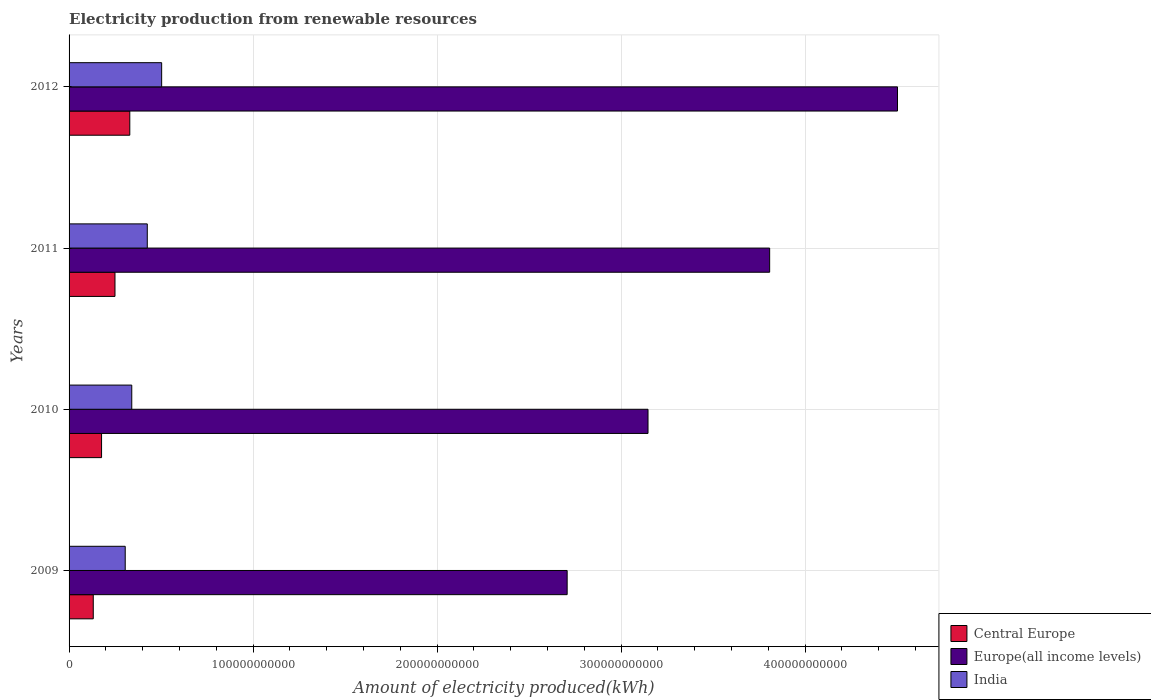How many groups of bars are there?
Make the answer very short. 4. Are the number of bars per tick equal to the number of legend labels?
Give a very brief answer. Yes. How many bars are there on the 1st tick from the bottom?
Your response must be concise. 3. What is the label of the 1st group of bars from the top?
Offer a terse response. 2012. In how many cases, is the number of bars for a given year not equal to the number of legend labels?
Offer a terse response. 0. What is the amount of electricity produced in Europe(all income levels) in 2011?
Make the answer very short. 3.81e+11. Across all years, what is the maximum amount of electricity produced in India?
Keep it short and to the point. 5.03e+1. Across all years, what is the minimum amount of electricity produced in Europe(all income levels)?
Make the answer very short. 2.71e+11. In which year was the amount of electricity produced in Central Europe minimum?
Your answer should be compact. 2009. What is the total amount of electricity produced in Central Europe in the graph?
Offer a terse response. 8.87e+1. What is the difference between the amount of electricity produced in Central Europe in 2009 and that in 2011?
Your answer should be very brief. -1.18e+1. What is the difference between the amount of electricity produced in Europe(all income levels) in 2009 and the amount of electricity produced in Central Europe in 2011?
Make the answer very short. 2.46e+11. What is the average amount of electricity produced in Central Europe per year?
Provide a short and direct response. 2.22e+1. In the year 2012, what is the difference between the amount of electricity produced in India and amount of electricity produced in Europe(all income levels)?
Ensure brevity in your answer.  -4.00e+11. What is the ratio of the amount of electricity produced in India in 2010 to that in 2011?
Keep it short and to the point. 0.8. Is the difference between the amount of electricity produced in India in 2011 and 2012 greater than the difference between the amount of electricity produced in Europe(all income levels) in 2011 and 2012?
Make the answer very short. Yes. What is the difference between the highest and the second highest amount of electricity produced in Europe(all income levels)?
Provide a short and direct response. 6.95e+1. What is the difference between the highest and the lowest amount of electricity produced in Central Europe?
Provide a succinct answer. 1.99e+1. What does the 1st bar from the top in 2009 represents?
Offer a terse response. India. What does the 2nd bar from the bottom in 2009 represents?
Make the answer very short. Europe(all income levels). What is the difference between two consecutive major ticks on the X-axis?
Your response must be concise. 1.00e+11. Where does the legend appear in the graph?
Provide a succinct answer. Bottom right. How many legend labels are there?
Offer a terse response. 3. What is the title of the graph?
Provide a short and direct response. Electricity production from renewable resources. Does "Ukraine" appear as one of the legend labels in the graph?
Provide a short and direct response. No. What is the label or title of the X-axis?
Keep it short and to the point. Amount of electricity produced(kWh). What is the label or title of the Y-axis?
Your response must be concise. Years. What is the Amount of electricity produced(kWh) of Central Europe in 2009?
Offer a very short reply. 1.31e+1. What is the Amount of electricity produced(kWh) in Europe(all income levels) in 2009?
Your answer should be very brief. 2.71e+11. What is the Amount of electricity produced(kWh) in India in 2009?
Offer a very short reply. 3.05e+1. What is the Amount of electricity produced(kWh) in Central Europe in 2010?
Your answer should be very brief. 1.77e+1. What is the Amount of electricity produced(kWh) in Europe(all income levels) in 2010?
Your answer should be very brief. 3.15e+11. What is the Amount of electricity produced(kWh) in India in 2010?
Offer a terse response. 3.41e+1. What is the Amount of electricity produced(kWh) in Central Europe in 2011?
Make the answer very short. 2.50e+1. What is the Amount of electricity produced(kWh) in Europe(all income levels) in 2011?
Give a very brief answer. 3.81e+11. What is the Amount of electricity produced(kWh) of India in 2011?
Your answer should be compact. 4.25e+1. What is the Amount of electricity produced(kWh) in Central Europe in 2012?
Offer a terse response. 3.30e+1. What is the Amount of electricity produced(kWh) in Europe(all income levels) in 2012?
Offer a terse response. 4.50e+11. What is the Amount of electricity produced(kWh) of India in 2012?
Your answer should be very brief. 5.03e+1. Across all years, what is the maximum Amount of electricity produced(kWh) in Central Europe?
Provide a succinct answer. 3.30e+1. Across all years, what is the maximum Amount of electricity produced(kWh) of Europe(all income levels)?
Give a very brief answer. 4.50e+11. Across all years, what is the maximum Amount of electricity produced(kWh) of India?
Offer a very short reply. 5.03e+1. Across all years, what is the minimum Amount of electricity produced(kWh) of Central Europe?
Keep it short and to the point. 1.31e+1. Across all years, what is the minimum Amount of electricity produced(kWh) in Europe(all income levels)?
Provide a short and direct response. 2.71e+11. Across all years, what is the minimum Amount of electricity produced(kWh) in India?
Your response must be concise. 3.05e+1. What is the total Amount of electricity produced(kWh) of Central Europe in the graph?
Provide a succinct answer. 8.87e+1. What is the total Amount of electricity produced(kWh) in Europe(all income levels) in the graph?
Ensure brevity in your answer.  1.42e+12. What is the total Amount of electricity produced(kWh) of India in the graph?
Ensure brevity in your answer.  1.57e+11. What is the difference between the Amount of electricity produced(kWh) of Central Europe in 2009 and that in 2010?
Ensure brevity in your answer.  -4.51e+09. What is the difference between the Amount of electricity produced(kWh) of Europe(all income levels) in 2009 and that in 2010?
Make the answer very short. -4.39e+1. What is the difference between the Amount of electricity produced(kWh) in India in 2009 and that in 2010?
Provide a short and direct response. -3.55e+09. What is the difference between the Amount of electricity produced(kWh) in Central Europe in 2009 and that in 2011?
Keep it short and to the point. -1.18e+1. What is the difference between the Amount of electricity produced(kWh) of Europe(all income levels) in 2009 and that in 2011?
Give a very brief answer. -1.10e+11. What is the difference between the Amount of electricity produced(kWh) of India in 2009 and that in 2011?
Your answer should be compact. -1.20e+1. What is the difference between the Amount of electricity produced(kWh) of Central Europe in 2009 and that in 2012?
Keep it short and to the point. -1.99e+1. What is the difference between the Amount of electricity produced(kWh) in Europe(all income levels) in 2009 and that in 2012?
Make the answer very short. -1.80e+11. What is the difference between the Amount of electricity produced(kWh) in India in 2009 and that in 2012?
Your response must be concise. -1.98e+1. What is the difference between the Amount of electricity produced(kWh) of Central Europe in 2010 and that in 2011?
Your answer should be compact. -7.30e+09. What is the difference between the Amount of electricity produced(kWh) in Europe(all income levels) in 2010 and that in 2011?
Keep it short and to the point. -6.61e+1. What is the difference between the Amount of electricity produced(kWh) in India in 2010 and that in 2011?
Your answer should be compact. -8.43e+09. What is the difference between the Amount of electricity produced(kWh) of Central Europe in 2010 and that in 2012?
Provide a succinct answer. -1.53e+1. What is the difference between the Amount of electricity produced(kWh) of Europe(all income levels) in 2010 and that in 2012?
Keep it short and to the point. -1.36e+11. What is the difference between the Amount of electricity produced(kWh) in India in 2010 and that in 2012?
Your response must be concise. -1.62e+1. What is the difference between the Amount of electricity produced(kWh) in Central Europe in 2011 and that in 2012?
Your answer should be very brief. -8.05e+09. What is the difference between the Amount of electricity produced(kWh) in Europe(all income levels) in 2011 and that in 2012?
Offer a very short reply. -6.95e+1. What is the difference between the Amount of electricity produced(kWh) in India in 2011 and that in 2012?
Your answer should be compact. -7.82e+09. What is the difference between the Amount of electricity produced(kWh) in Central Europe in 2009 and the Amount of electricity produced(kWh) in Europe(all income levels) in 2010?
Give a very brief answer. -3.01e+11. What is the difference between the Amount of electricity produced(kWh) of Central Europe in 2009 and the Amount of electricity produced(kWh) of India in 2010?
Your answer should be compact. -2.09e+1. What is the difference between the Amount of electricity produced(kWh) of Europe(all income levels) in 2009 and the Amount of electricity produced(kWh) of India in 2010?
Give a very brief answer. 2.37e+11. What is the difference between the Amount of electricity produced(kWh) of Central Europe in 2009 and the Amount of electricity produced(kWh) of Europe(all income levels) in 2011?
Make the answer very short. -3.68e+11. What is the difference between the Amount of electricity produced(kWh) of Central Europe in 2009 and the Amount of electricity produced(kWh) of India in 2011?
Make the answer very short. -2.94e+1. What is the difference between the Amount of electricity produced(kWh) of Europe(all income levels) in 2009 and the Amount of electricity produced(kWh) of India in 2011?
Offer a terse response. 2.28e+11. What is the difference between the Amount of electricity produced(kWh) in Central Europe in 2009 and the Amount of electricity produced(kWh) in Europe(all income levels) in 2012?
Keep it short and to the point. -4.37e+11. What is the difference between the Amount of electricity produced(kWh) of Central Europe in 2009 and the Amount of electricity produced(kWh) of India in 2012?
Provide a short and direct response. -3.72e+1. What is the difference between the Amount of electricity produced(kWh) of Europe(all income levels) in 2009 and the Amount of electricity produced(kWh) of India in 2012?
Make the answer very short. 2.20e+11. What is the difference between the Amount of electricity produced(kWh) of Central Europe in 2010 and the Amount of electricity produced(kWh) of Europe(all income levels) in 2011?
Offer a terse response. -3.63e+11. What is the difference between the Amount of electricity produced(kWh) in Central Europe in 2010 and the Amount of electricity produced(kWh) in India in 2011?
Offer a terse response. -2.48e+1. What is the difference between the Amount of electricity produced(kWh) in Europe(all income levels) in 2010 and the Amount of electricity produced(kWh) in India in 2011?
Your answer should be very brief. 2.72e+11. What is the difference between the Amount of electricity produced(kWh) in Central Europe in 2010 and the Amount of electricity produced(kWh) in Europe(all income levels) in 2012?
Your response must be concise. -4.33e+11. What is the difference between the Amount of electricity produced(kWh) in Central Europe in 2010 and the Amount of electricity produced(kWh) in India in 2012?
Provide a succinct answer. -3.27e+1. What is the difference between the Amount of electricity produced(kWh) of Europe(all income levels) in 2010 and the Amount of electricity produced(kWh) of India in 2012?
Keep it short and to the point. 2.64e+11. What is the difference between the Amount of electricity produced(kWh) in Central Europe in 2011 and the Amount of electricity produced(kWh) in Europe(all income levels) in 2012?
Offer a very short reply. -4.25e+11. What is the difference between the Amount of electricity produced(kWh) in Central Europe in 2011 and the Amount of electricity produced(kWh) in India in 2012?
Keep it short and to the point. -2.54e+1. What is the difference between the Amount of electricity produced(kWh) of Europe(all income levels) in 2011 and the Amount of electricity produced(kWh) of India in 2012?
Make the answer very short. 3.30e+11. What is the average Amount of electricity produced(kWh) of Central Europe per year?
Your answer should be very brief. 2.22e+1. What is the average Amount of electricity produced(kWh) in Europe(all income levels) per year?
Provide a short and direct response. 3.54e+11. What is the average Amount of electricity produced(kWh) in India per year?
Make the answer very short. 3.93e+1. In the year 2009, what is the difference between the Amount of electricity produced(kWh) of Central Europe and Amount of electricity produced(kWh) of Europe(all income levels)?
Provide a succinct answer. -2.58e+11. In the year 2009, what is the difference between the Amount of electricity produced(kWh) of Central Europe and Amount of electricity produced(kWh) of India?
Give a very brief answer. -1.74e+1. In the year 2009, what is the difference between the Amount of electricity produced(kWh) of Europe(all income levels) and Amount of electricity produced(kWh) of India?
Offer a very short reply. 2.40e+11. In the year 2010, what is the difference between the Amount of electricity produced(kWh) in Central Europe and Amount of electricity produced(kWh) in Europe(all income levels)?
Provide a succinct answer. -2.97e+11. In the year 2010, what is the difference between the Amount of electricity produced(kWh) in Central Europe and Amount of electricity produced(kWh) in India?
Your answer should be compact. -1.64e+1. In the year 2010, what is the difference between the Amount of electricity produced(kWh) of Europe(all income levels) and Amount of electricity produced(kWh) of India?
Give a very brief answer. 2.81e+11. In the year 2011, what is the difference between the Amount of electricity produced(kWh) of Central Europe and Amount of electricity produced(kWh) of Europe(all income levels)?
Give a very brief answer. -3.56e+11. In the year 2011, what is the difference between the Amount of electricity produced(kWh) of Central Europe and Amount of electricity produced(kWh) of India?
Your response must be concise. -1.75e+1. In the year 2011, what is the difference between the Amount of electricity produced(kWh) in Europe(all income levels) and Amount of electricity produced(kWh) in India?
Provide a succinct answer. 3.38e+11. In the year 2012, what is the difference between the Amount of electricity produced(kWh) in Central Europe and Amount of electricity produced(kWh) in Europe(all income levels)?
Offer a very short reply. -4.17e+11. In the year 2012, what is the difference between the Amount of electricity produced(kWh) of Central Europe and Amount of electricity produced(kWh) of India?
Ensure brevity in your answer.  -1.73e+1. In the year 2012, what is the difference between the Amount of electricity produced(kWh) of Europe(all income levels) and Amount of electricity produced(kWh) of India?
Provide a succinct answer. 4.00e+11. What is the ratio of the Amount of electricity produced(kWh) in Central Europe in 2009 to that in 2010?
Ensure brevity in your answer.  0.74. What is the ratio of the Amount of electricity produced(kWh) of Europe(all income levels) in 2009 to that in 2010?
Your answer should be compact. 0.86. What is the ratio of the Amount of electricity produced(kWh) in India in 2009 to that in 2010?
Provide a short and direct response. 0.9. What is the ratio of the Amount of electricity produced(kWh) of Central Europe in 2009 to that in 2011?
Provide a short and direct response. 0.53. What is the ratio of the Amount of electricity produced(kWh) of Europe(all income levels) in 2009 to that in 2011?
Your answer should be very brief. 0.71. What is the ratio of the Amount of electricity produced(kWh) in India in 2009 to that in 2011?
Provide a short and direct response. 0.72. What is the ratio of the Amount of electricity produced(kWh) of Central Europe in 2009 to that in 2012?
Provide a short and direct response. 0.4. What is the ratio of the Amount of electricity produced(kWh) in Europe(all income levels) in 2009 to that in 2012?
Offer a very short reply. 0.6. What is the ratio of the Amount of electricity produced(kWh) of India in 2009 to that in 2012?
Your answer should be very brief. 0.61. What is the ratio of the Amount of electricity produced(kWh) of Central Europe in 2010 to that in 2011?
Make the answer very short. 0.71. What is the ratio of the Amount of electricity produced(kWh) of Europe(all income levels) in 2010 to that in 2011?
Ensure brevity in your answer.  0.83. What is the ratio of the Amount of electricity produced(kWh) of India in 2010 to that in 2011?
Offer a terse response. 0.8. What is the ratio of the Amount of electricity produced(kWh) of Central Europe in 2010 to that in 2012?
Give a very brief answer. 0.54. What is the ratio of the Amount of electricity produced(kWh) in Europe(all income levels) in 2010 to that in 2012?
Keep it short and to the point. 0.7. What is the ratio of the Amount of electricity produced(kWh) of India in 2010 to that in 2012?
Your response must be concise. 0.68. What is the ratio of the Amount of electricity produced(kWh) of Central Europe in 2011 to that in 2012?
Provide a short and direct response. 0.76. What is the ratio of the Amount of electricity produced(kWh) in Europe(all income levels) in 2011 to that in 2012?
Offer a very short reply. 0.85. What is the ratio of the Amount of electricity produced(kWh) of India in 2011 to that in 2012?
Your response must be concise. 0.84. What is the difference between the highest and the second highest Amount of electricity produced(kWh) in Central Europe?
Your answer should be very brief. 8.05e+09. What is the difference between the highest and the second highest Amount of electricity produced(kWh) of Europe(all income levels)?
Ensure brevity in your answer.  6.95e+1. What is the difference between the highest and the second highest Amount of electricity produced(kWh) of India?
Your answer should be very brief. 7.82e+09. What is the difference between the highest and the lowest Amount of electricity produced(kWh) in Central Europe?
Provide a short and direct response. 1.99e+1. What is the difference between the highest and the lowest Amount of electricity produced(kWh) in Europe(all income levels)?
Make the answer very short. 1.80e+11. What is the difference between the highest and the lowest Amount of electricity produced(kWh) in India?
Keep it short and to the point. 1.98e+1. 